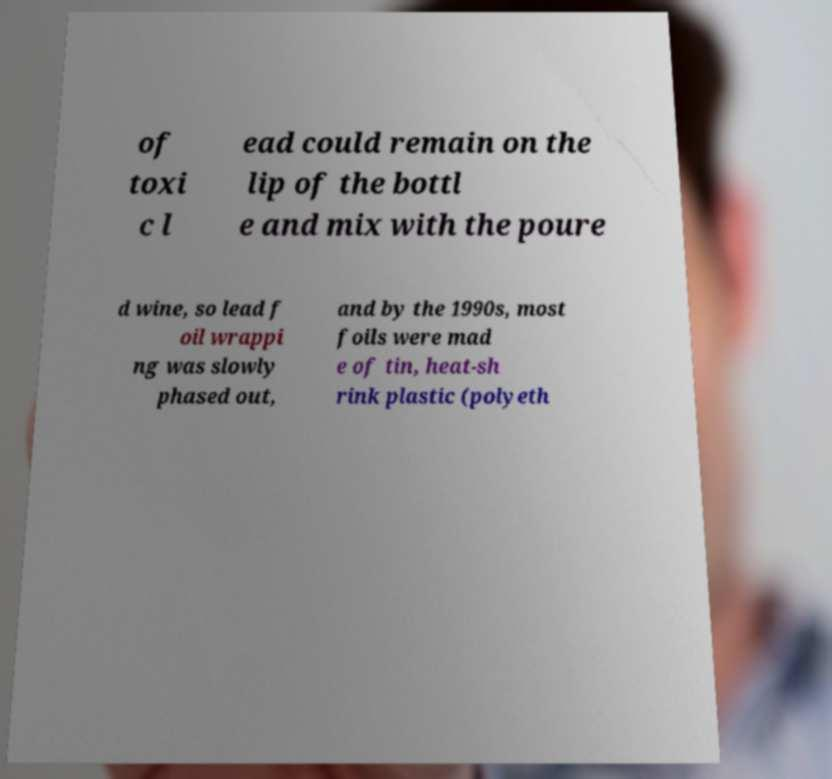There's text embedded in this image that I need extracted. Can you transcribe it verbatim? of toxi c l ead could remain on the lip of the bottl e and mix with the poure d wine, so lead f oil wrappi ng was slowly phased out, and by the 1990s, most foils were mad e of tin, heat-sh rink plastic (polyeth 